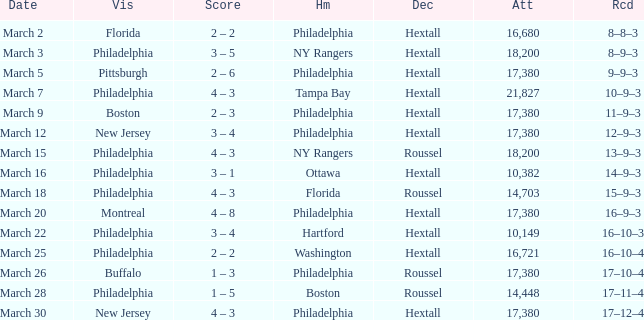Date of march 30 involves what home? Philadelphia. 